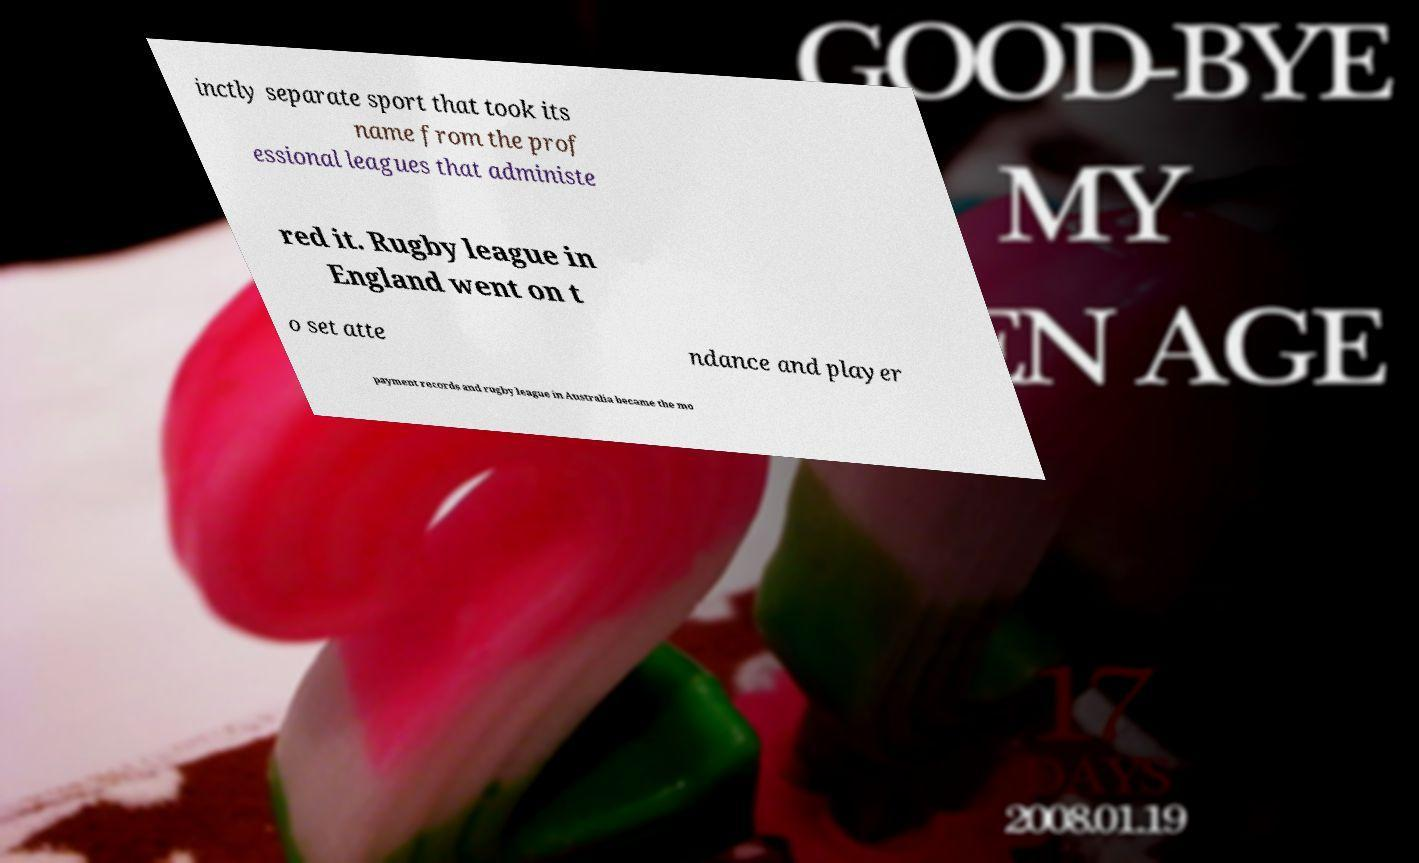Please identify and transcribe the text found in this image. inctly separate sport that took its name from the prof essional leagues that administe red it. Rugby league in England went on t o set atte ndance and player payment records and rugby league in Australia became the mo 